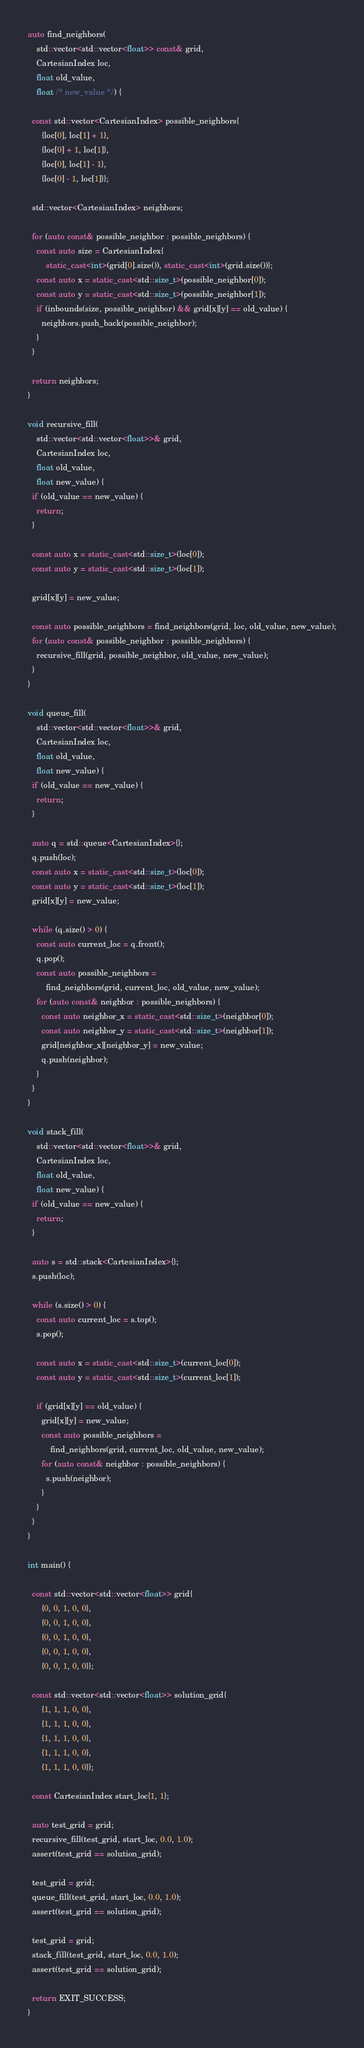<code> <loc_0><loc_0><loc_500><loc_500><_C++_>
auto find_neighbors(
    std::vector<std::vector<float>> const& grid,
    CartesianIndex loc,
    float old_value,
    float /* new_value */) {

  const std::vector<CartesianIndex> possible_neighbors{
      {loc[0], loc[1] + 1},
      {loc[0] + 1, loc[1]},
      {loc[0], loc[1] - 1},
      {loc[0] - 1, loc[1]}};

  std::vector<CartesianIndex> neighbors;

  for (auto const& possible_neighbor : possible_neighbors) {
    const auto size = CartesianIndex{
        static_cast<int>(grid[0].size()), static_cast<int>(grid.size())};
    const auto x = static_cast<std::size_t>(possible_neighbor[0]);
    const auto y = static_cast<std::size_t>(possible_neighbor[1]);
    if (inbounds(size, possible_neighbor) && grid[x][y] == old_value) {
      neighbors.push_back(possible_neighbor);
    }
  }

  return neighbors;
}

void recursive_fill(
    std::vector<std::vector<float>>& grid,
    CartesianIndex loc,
    float old_value,
    float new_value) {
  if (old_value == new_value) {
    return;
  }

  const auto x = static_cast<std::size_t>(loc[0]);
  const auto y = static_cast<std::size_t>(loc[1]);

  grid[x][y] = new_value;

  const auto possible_neighbors = find_neighbors(grid, loc, old_value, new_value);
  for (auto const& possible_neighbor : possible_neighbors) {
    recursive_fill(grid, possible_neighbor, old_value, new_value);
  }
}

void queue_fill(
    std::vector<std::vector<float>>& grid,
    CartesianIndex loc,
    float old_value,
    float new_value) {
  if (old_value == new_value) {
    return;
  }

  auto q = std::queue<CartesianIndex>{};
  q.push(loc);
  const auto x = static_cast<std::size_t>(loc[0]);
  const auto y = static_cast<std::size_t>(loc[1]);
  grid[x][y] = new_value;

  while (q.size() > 0) {
    const auto current_loc = q.front();
    q.pop();
    const auto possible_neighbors =
        find_neighbors(grid, current_loc, old_value, new_value);
    for (auto const& neighbor : possible_neighbors) {
      const auto neighbor_x = static_cast<std::size_t>(neighbor[0]);
      const auto neighbor_y = static_cast<std::size_t>(neighbor[1]);
      grid[neighbor_x][neighbor_y] = new_value;
      q.push(neighbor);
    }
  }
}

void stack_fill(
    std::vector<std::vector<float>>& grid,
    CartesianIndex loc,
    float old_value,
    float new_value) {
  if (old_value == new_value) {
    return;
  }

  auto s = std::stack<CartesianIndex>{};
  s.push(loc);

  while (s.size() > 0) {
    const auto current_loc = s.top();
    s.pop();

    const auto x = static_cast<std::size_t>(current_loc[0]);
    const auto y = static_cast<std::size_t>(current_loc[1]);

    if (grid[x][y] == old_value) {
      grid[x][y] = new_value;
      const auto possible_neighbors =
          find_neighbors(grid, current_loc, old_value, new_value);
      for (auto const& neighbor : possible_neighbors) {
        s.push(neighbor);
      }
    }
  }
}

int main() {

  const std::vector<std::vector<float>> grid{
      {0, 0, 1, 0, 0},
      {0, 0, 1, 0, 0},
      {0, 0, 1, 0, 0},
      {0, 0, 1, 0, 0},
      {0, 0, 1, 0, 0}};

  const std::vector<std::vector<float>> solution_grid{
      {1, 1, 1, 0, 0},
      {1, 1, 1, 0, 0},
      {1, 1, 1, 0, 0},
      {1, 1, 1, 0, 0},
      {1, 1, 1, 0, 0}};

  const CartesianIndex start_loc{1, 1};

  auto test_grid = grid;
  recursive_fill(test_grid, start_loc, 0.0, 1.0);
  assert(test_grid == solution_grid);

  test_grid = grid;
  queue_fill(test_grid, start_loc, 0.0, 1.0);
  assert(test_grid == solution_grid);

  test_grid = grid;
  stack_fill(test_grid, start_loc, 0.0, 1.0);
  assert(test_grid == solution_grid);

  return EXIT_SUCCESS;
}</code> 